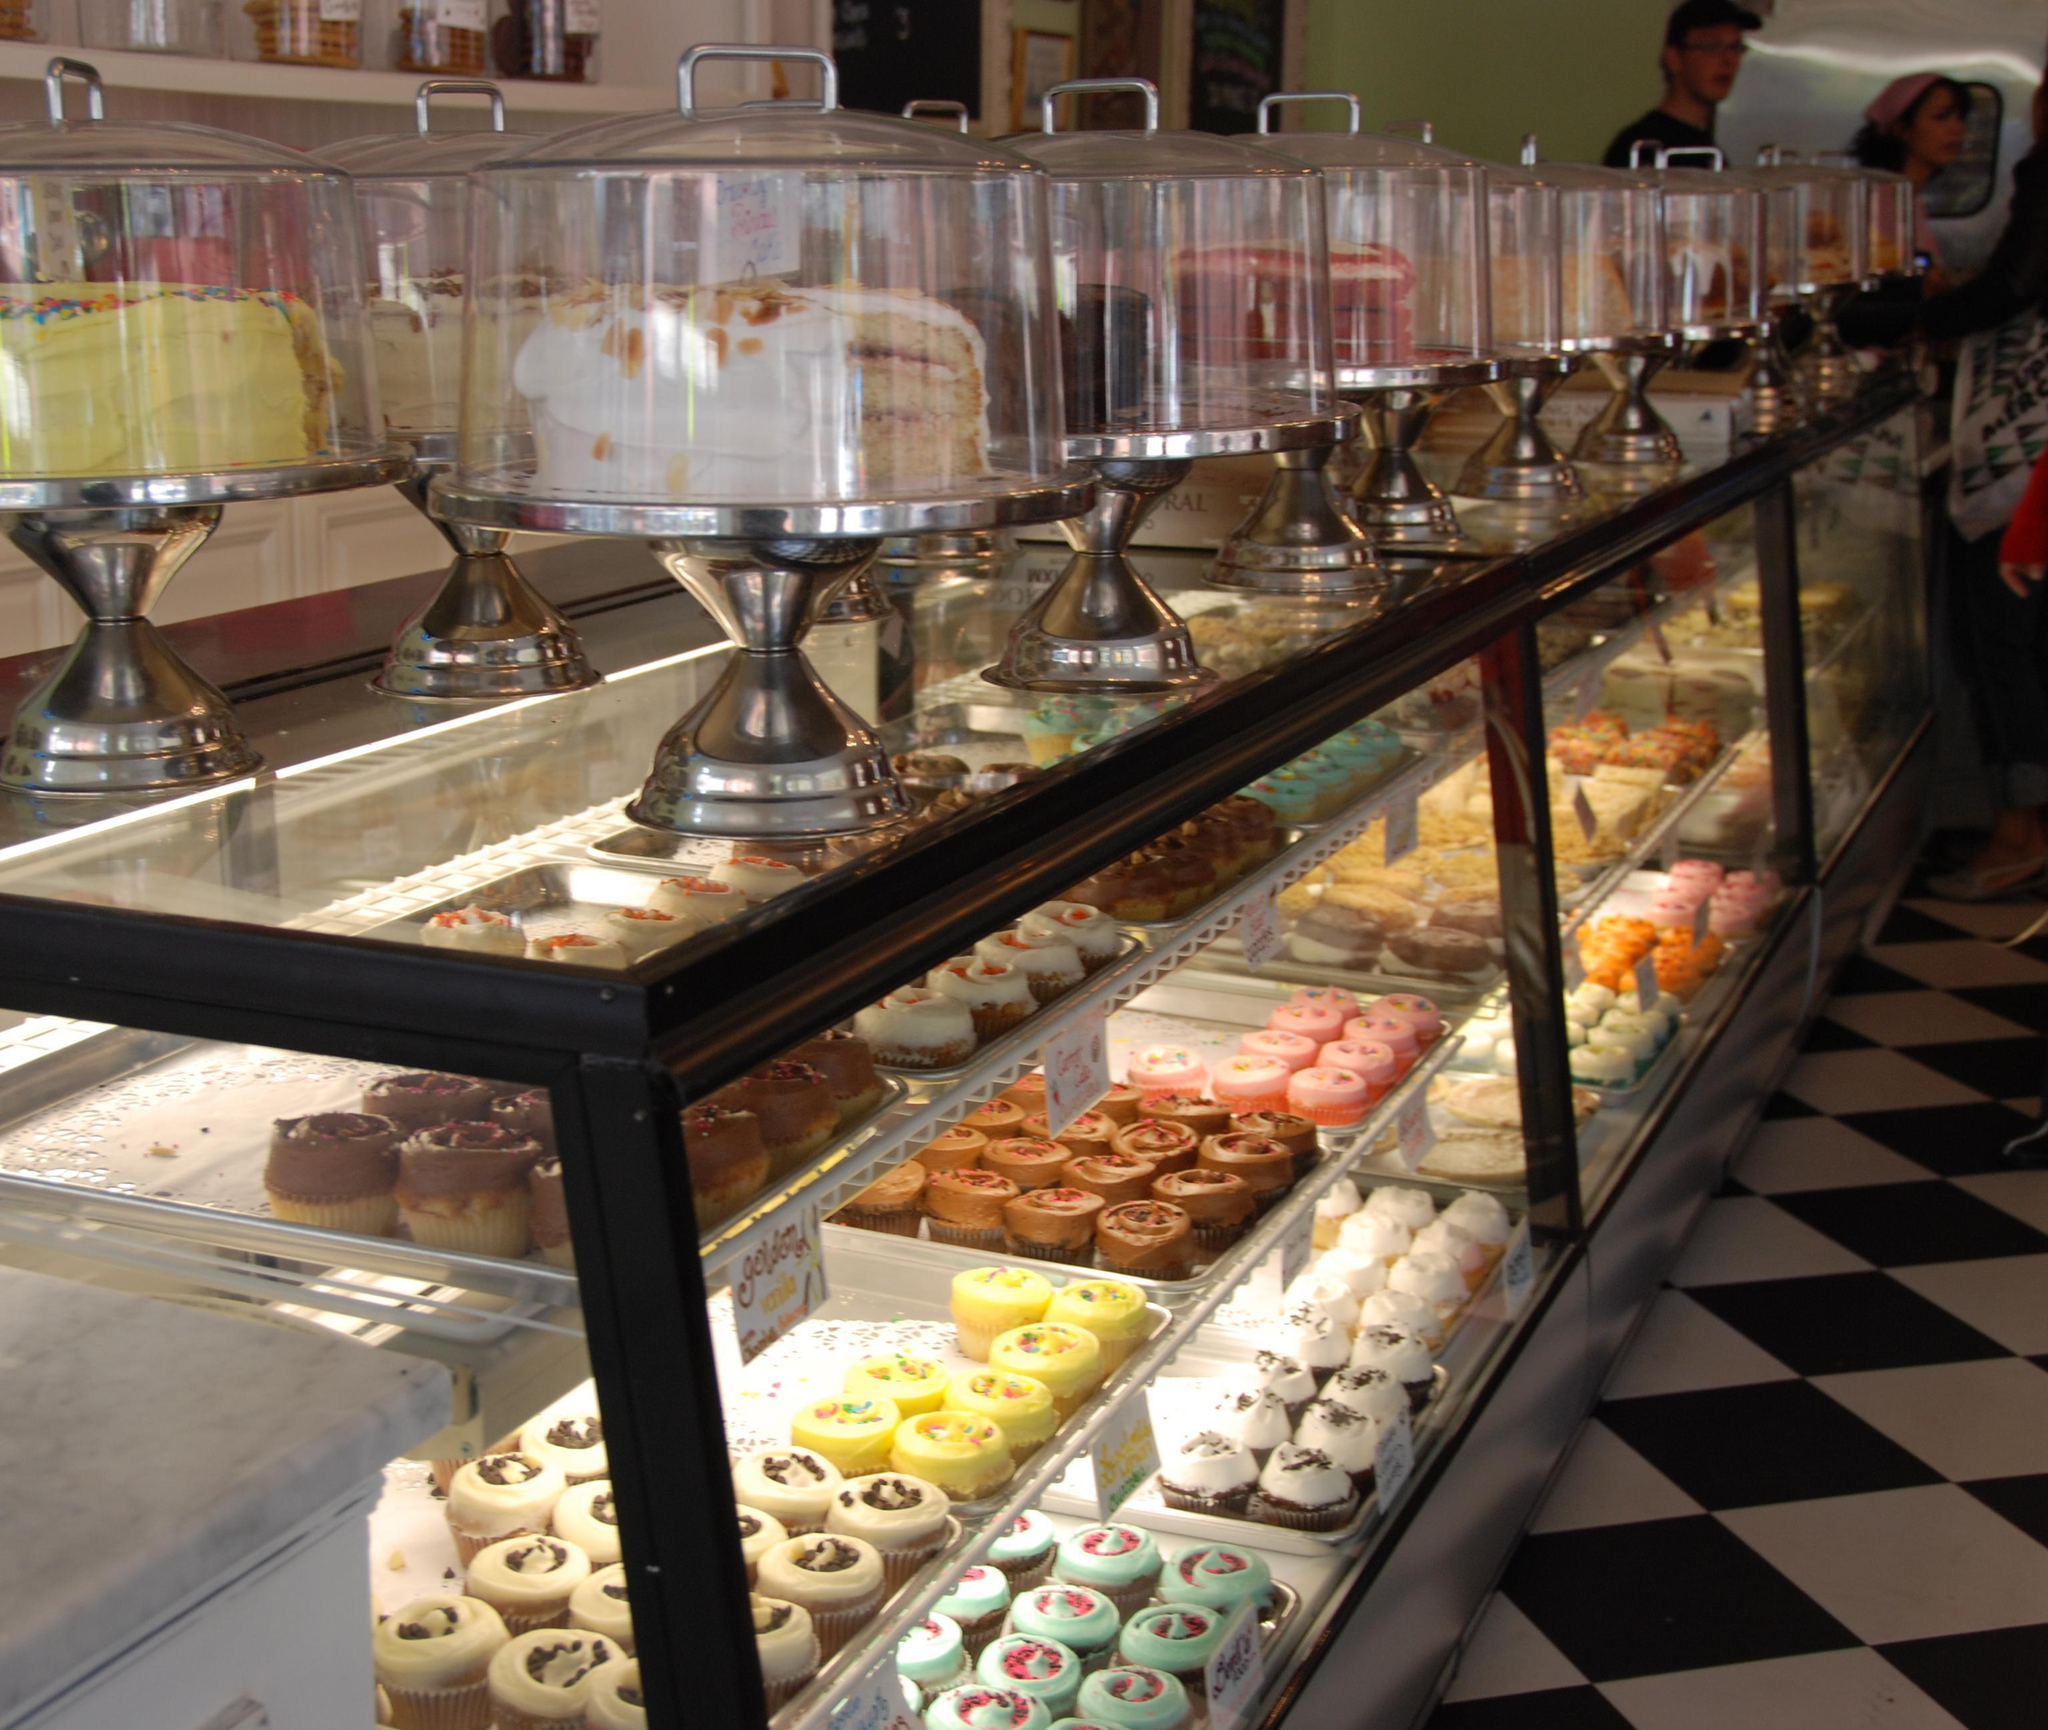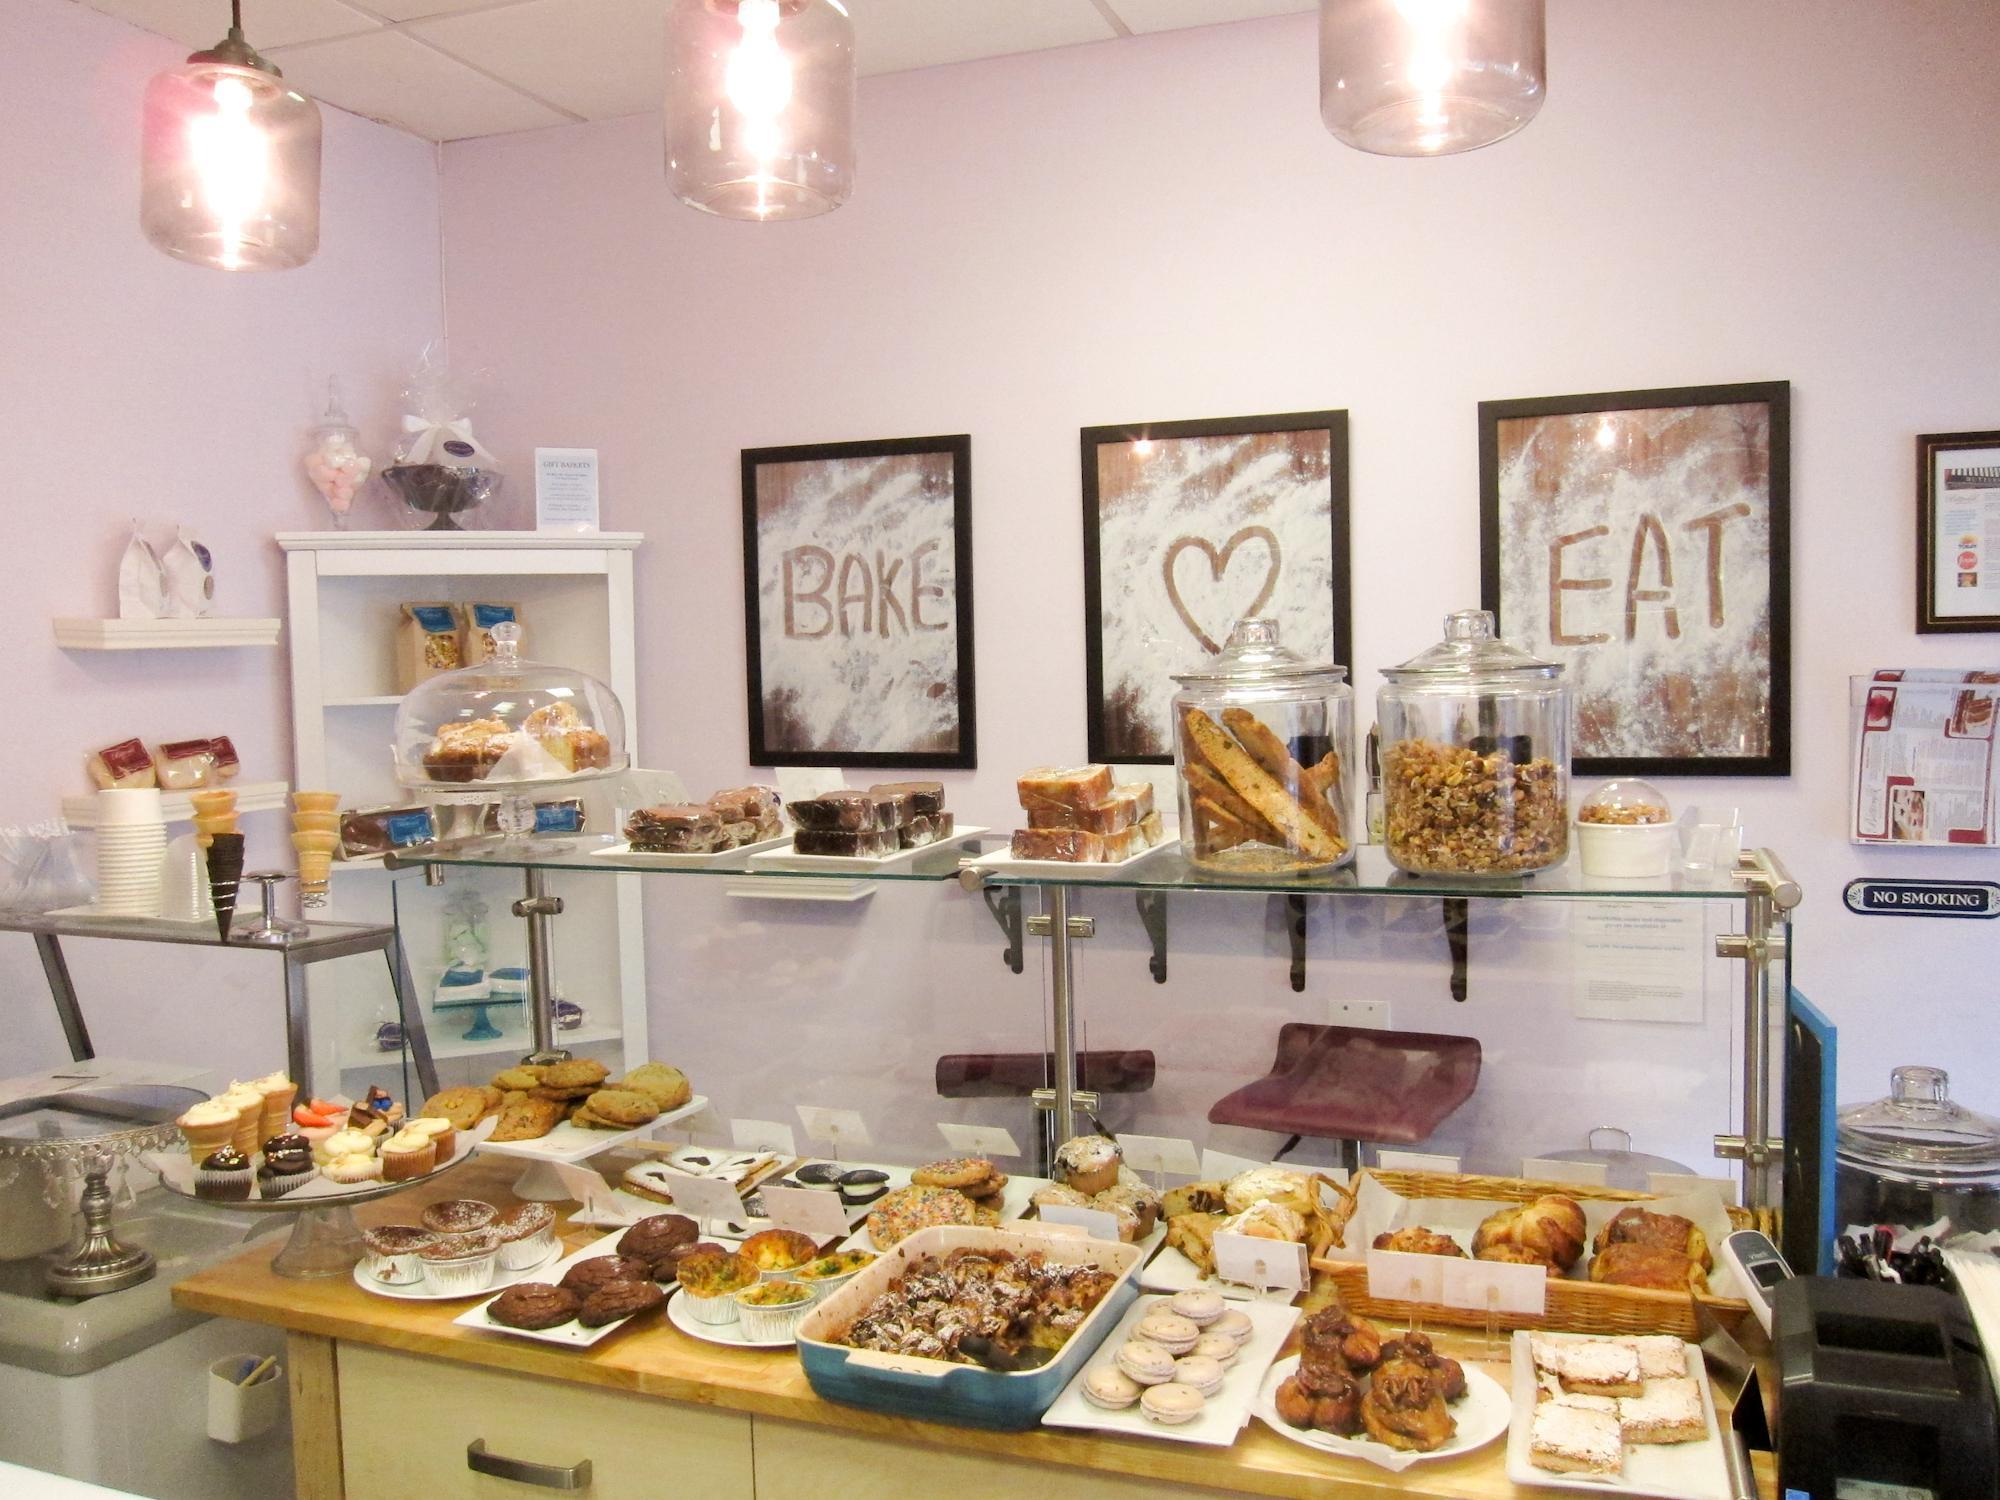The first image is the image on the left, the second image is the image on the right. For the images displayed, is the sentence "One of the images shows the flooring in front of a glass fronted display case." factually correct? Answer yes or no. Yes. 